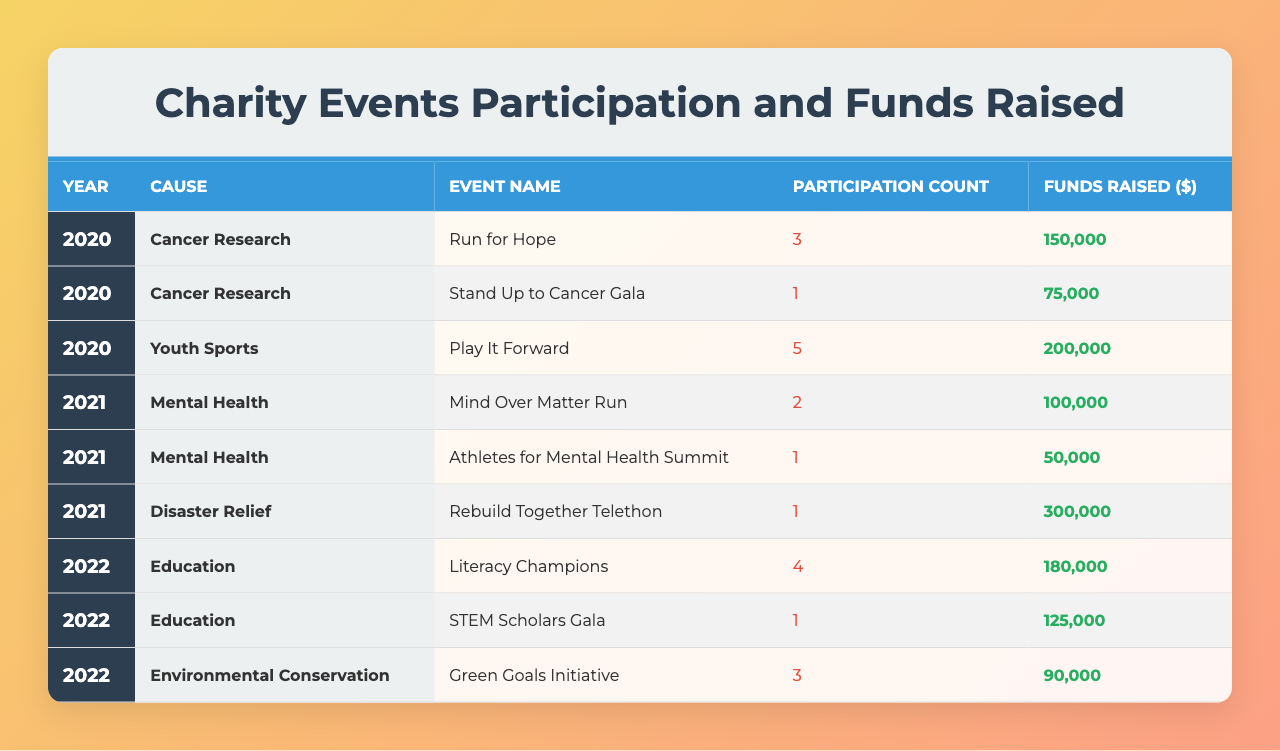What was the total funds raised for Cancer Research in 2020? In 2020, there were two events for Cancer Research: "Run for Hope" raised $150,000 and "Stand Up to Cancer Gala" raised $75,000. Adding these amounts gives a total of $150,000 + $75,000 = $225,000.
Answer: $225,000 How many total participants were there in Youth Sports events in 2020? The only event in 2020 for Youth Sports was "Play It Forward," which had a participation count of 5. Therefore, the total participants are simply 5.
Answer: 5 Which cause had the highest funds raised in 2021? In 2021, the causes were Mental Health and Disaster Relief. Mental Health raised $100,000 from two events, and Disaster Relief raised $300,000 from one event. Comparing these, Disaster Relief had the highest amount, totaling $300,000.
Answer: Disaster Relief What is the average funds raised per event for Education in 2022? In 2022, there were two events for Education: "Literacy Champions" raised $180,000 and "STEM Scholars Gala" raised $125,000. The total funds raised is $180,000 + $125,000 = $305,000. There are 2 events, so the average raised per event is $305,000 / 2 = $152,500.
Answer: $152,500 Did the participation count in 2021 for Mental Health exceed that of any event in 2020? In 2021, the Mental Health events had a participation count of 2 (Mind Over Matter Run) and 1 (Athletes for Mental Health Summit), totaling 3. In 2020, the highest participation count was 5 (Play It Forward), which is greater than 3. Therefore, the answer is no.
Answer: No How much more was raised for Disaster Relief compared to Mental Health in 2021? Disaster Relief raised $300,000 while Mental Health raised $100,000 in 2021. To find the difference, subtract the funds raised for Mental Health from Disaster Relief: $300,000 - $100,000 = $200,000.
Answer: $200,000 What was the participation count for Environmental Conservation in 2022? In 2022, there was one event for Environmental Conservation called "Green Goals Initiative," which had a participation count of 3. Therefore, the participation count is 3.
Answer: 3 Which year saw the highest total funds raised across all causes? Totaling funds raised for each year: 2020 had $225,000 (Cancer Research) + $200,000 (Youth Sports) = $425,000; 2021 had $300,000 (Disaster Relief) + $150,000 (Mental Health) = $450,000; 2022 had $305,000 (Education) + $90,000 (Environmental Conservation) = $395,000. The year with the highest total is 2021 with $450,000.
Answer: 2021 How many events were held for each cause across the recorded years? In total: Cancer Research had 2 events in 2020, Youth Sports had 1 event in 2020, Mental Health had 2 events in 2021, Disaster Relief had 1 event in 2021, Education had 2 events in 2022, and Environmental Conservation had 1 event in 2022. Summing these gives the total events: 2 + 1 + 2 + 1 + 2 + 1 = 9 events in total.
Answer: 9 events 